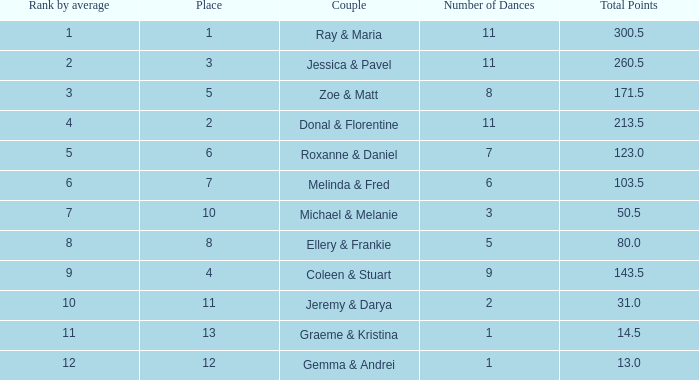What is the duo's name having a mean of 1 Coleen & Stuart. 